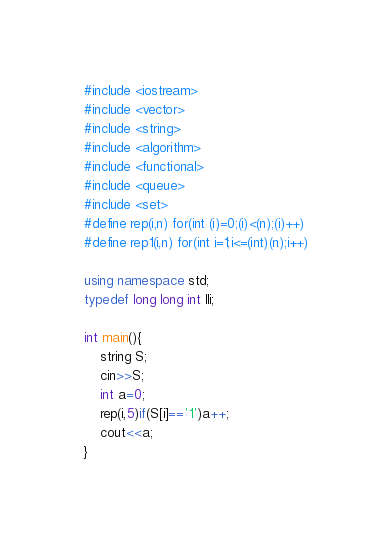<code> <loc_0><loc_0><loc_500><loc_500><_C++_>#include <iostream>
#include <vector>
#include <string>
#include <algorithm>
#include <functional>
#include <queue>
#include <set>
#define rep(i,n) for(int (i)=0;(i)<(n);(i)++)
#define rep1(i,n) for(int i=1;i<=(int)(n);i++)

using namespace std;
typedef long long int lli;

int main(){
	string S;
	cin>>S;
	int a=0;
	rep(i,5)if(S[i]=='1')a++;
	cout<<a;
}</code> 